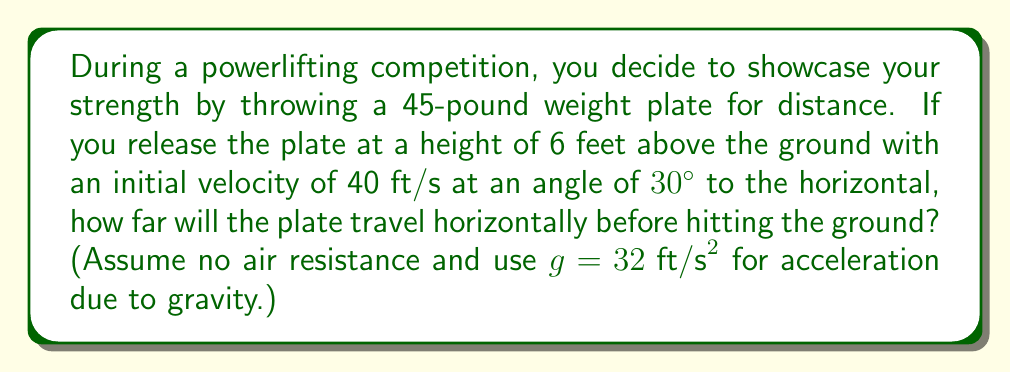Can you solve this math problem? Let's approach this step-by-step using the equations of projectile motion:

1) First, we need to break down the initial velocity into its horizontal and vertical components:

   $v_{0x} = v_0 \cos \theta = 40 \cos 30° = 40 \cdot \frac{\sqrt{3}}{2} \approx 34.64 \text{ ft/s}$
   $v_{0y} = v_0 \sin \theta = 40 \sin 30° = 40 \cdot \frac{1}{2} = 20 \text{ ft/s}$

2) The horizontal distance traveled is given by $x = v_{0x}t$, where $t$ is the time of flight.

3) To find $t$, we use the vertical motion equation:
   $y = y_0 + v_{0y}t - \frac{1}{2}gt^2$

4) At the point of impact, $y = 0$ and $y_0 = 6$ feet. Substituting these values:

   $0 = 6 + 20t - 16t^2$

5) Rearranging the equation:
   $16t^2 - 20t - 6 = 0$

6) This is a quadratic equation. We can solve it using the quadratic formula:
   $t = \frac{-b \pm \sqrt{b^2 - 4ac}}{2a}$

   Where $a = 16$, $b = -20$, and $c = -6$

7) Solving:
   $t = \frac{20 \pm \sqrt{400 + 384}}{32} = \frac{20 \pm \sqrt{784}}{32} = \frac{20 \pm 28}{32}$

8) We take the positive root as time cannot be negative:
   $t = \frac{20 + 28}{32} = \frac{48}{32} = 1.5 \text{ seconds}$

9) Now we can find the horizontal distance:
   $x = v_{0x}t = 34.64 \cdot 1.5 \approx 51.96 \text{ feet}$

Therefore, the weight plate will travel approximately 52 feet horizontally before hitting the ground.
Answer: 52 feet 